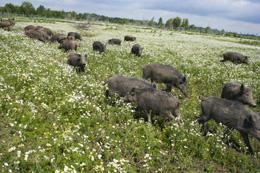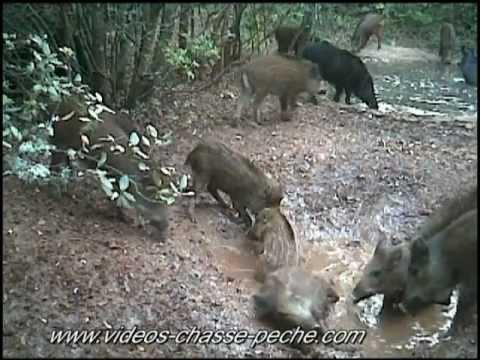The first image is the image on the left, the second image is the image on the right. Analyze the images presented: Is the assertion "The animals in one of the images are moving directly toward the camera." valid? Answer yes or no. No. The first image is the image on the left, the second image is the image on the right. Evaluate the accuracy of this statement regarding the images: "One image shows a group of hogs on a bright green field.". Is it true? Answer yes or no. Yes. 